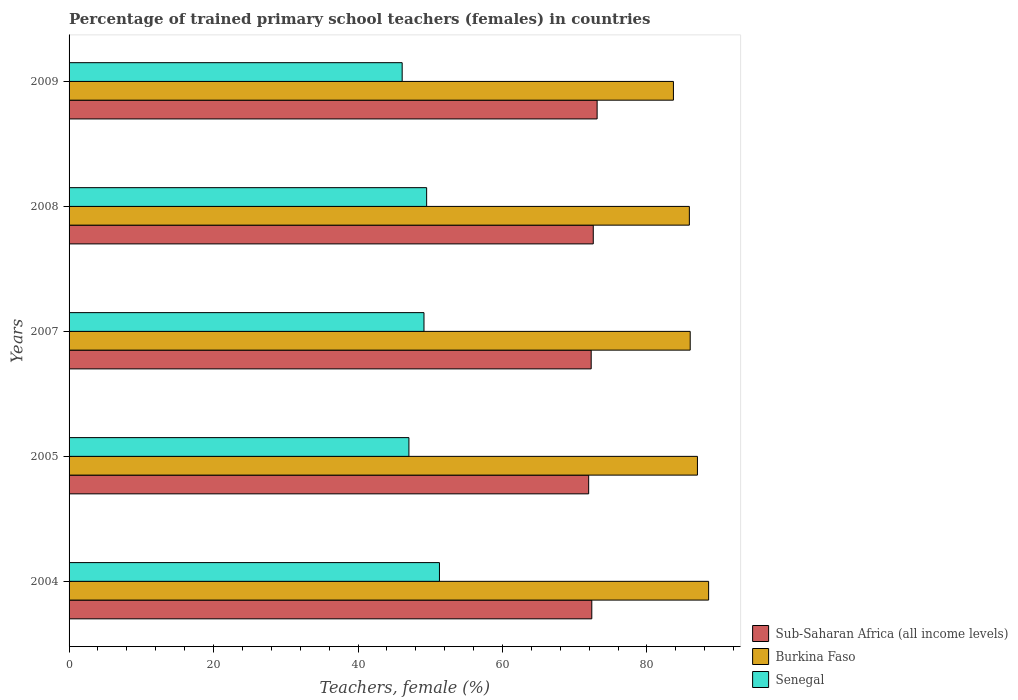How many groups of bars are there?
Your answer should be very brief. 5. How many bars are there on the 1st tick from the bottom?
Provide a succinct answer. 3. What is the label of the 4th group of bars from the top?
Keep it short and to the point. 2005. What is the percentage of trained primary school teachers (females) in Burkina Faso in 2007?
Provide a short and direct response. 85.99. Across all years, what is the maximum percentage of trained primary school teachers (females) in Burkina Faso?
Your answer should be very brief. 88.54. Across all years, what is the minimum percentage of trained primary school teachers (females) in Burkina Faso?
Make the answer very short. 83.67. What is the total percentage of trained primary school teachers (females) in Sub-Saharan Africa (all income levels) in the graph?
Provide a succinct answer. 362.25. What is the difference between the percentage of trained primary school teachers (females) in Senegal in 2007 and that in 2009?
Offer a very short reply. 3.02. What is the difference between the percentage of trained primary school teachers (females) in Sub-Saharan Africa (all income levels) in 2005 and the percentage of trained primary school teachers (females) in Burkina Faso in 2008?
Provide a short and direct response. -13.94. What is the average percentage of trained primary school teachers (females) in Burkina Faso per year?
Make the answer very short. 86.21. In the year 2009, what is the difference between the percentage of trained primary school teachers (females) in Burkina Faso and percentage of trained primary school teachers (females) in Senegal?
Give a very brief answer. 37.55. In how many years, is the percentage of trained primary school teachers (females) in Sub-Saharan Africa (all income levels) greater than 52 %?
Give a very brief answer. 5. What is the ratio of the percentage of trained primary school teachers (females) in Burkina Faso in 2007 to that in 2009?
Offer a terse response. 1.03. Is the percentage of trained primary school teachers (females) in Burkina Faso in 2004 less than that in 2009?
Provide a short and direct response. No. Is the difference between the percentage of trained primary school teachers (females) in Burkina Faso in 2004 and 2009 greater than the difference between the percentage of trained primary school teachers (females) in Senegal in 2004 and 2009?
Your response must be concise. No. What is the difference between the highest and the second highest percentage of trained primary school teachers (females) in Burkina Faso?
Make the answer very short. 1.55. What is the difference between the highest and the lowest percentage of trained primary school teachers (females) in Sub-Saharan Africa (all income levels)?
Offer a terse response. 1.17. In how many years, is the percentage of trained primary school teachers (females) in Sub-Saharan Africa (all income levels) greater than the average percentage of trained primary school teachers (females) in Sub-Saharan Africa (all income levels) taken over all years?
Your response must be concise. 2. What does the 3rd bar from the top in 2008 represents?
Offer a very short reply. Sub-Saharan Africa (all income levels). What does the 1st bar from the bottom in 2009 represents?
Offer a terse response. Sub-Saharan Africa (all income levels). How many bars are there?
Your answer should be very brief. 15. Are all the bars in the graph horizontal?
Your answer should be compact. Yes. What is the difference between two consecutive major ticks on the X-axis?
Your response must be concise. 20. Does the graph contain any zero values?
Offer a very short reply. No. How many legend labels are there?
Ensure brevity in your answer.  3. How are the legend labels stacked?
Your response must be concise. Vertical. What is the title of the graph?
Offer a terse response. Percentage of trained primary school teachers (females) in countries. Does "Oman" appear as one of the legend labels in the graph?
Give a very brief answer. No. What is the label or title of the X-axis?
Your answer should be very brief. Teachers, female (%). What is the Teachers, female (%) in Sub-Saharan Africa (all income levels) in 2004?
Provide a succinct answer. 72.37. What is the Teachers, female (%) in Burkina Faso in 2004?
Give a very brief answer. 88.54. What is the Teachers, female (%) in Senegal in 2004?
Your answer should be compact. 51.28. What is the Teachers, female (%) in Sub-Saharan Africa (all income levels) in 2005?
Provide a short and direct response. 71.93. What is the Teachers, female (%) of Burkina Faso in 2005?
Offer a terse response. 86.99. What is the Teachers, female (%) in Senegal in 2005?
Offer a very short reply. 47.05. What is the Teachers, female (%) of Sub-Saharan Africa (all income levels) in 2007?
Provide a short and direct response. 72.28. What is the Teachers, female (%) of Burkina Faso in 2007?
Keep it short and to the point. 85.99. What is the Teachers, female (%) of Senegal in 2007?
Your answer should be compact. 49.13. What is the Teachers, female (%) of Sub-Saharan Africa (all income levels) in 2008?
Provide a succinct answer. 72.57. What is the Teachers, female (%) of Burkina Faso in 2008?
Keep it short and to the point. 85.87. What is the Teachers, female (%) of Senegal in 2008?
Your response must be concise. 49.5. What is the Teachers, female (%) in Sub-Saharan Africa (all income levels) in 2009?
Keep it short and to the point. 73.1. What is the Teachers, female (%) in Burkina Faso in 2009?
Your answer should be very brief. 83.67. What is the Teachers, female (%) in Senegal in 2009?
Ensure brevity in your answer.  46.11. Across all years, what is the maximum Teachers, female (%) in Sub-Saharan Africa (all income levels)?
Give a very brief answer. 73.1. Across all years, what is the maximum Teachers, female (%) of Burkina Faso?
Offer a very short reply. 88.54. Across all years, what is the maximum Teachers, female (%) in Senegal?
Offer a terse response. 51.28. Across all years, what is the minimum Teachers, female (%) in Sub-Saharan Africa (all income levels)?
Your answer should be very brief. 71.93. Across all years, what is the minimum Teachers, female (%) in Burkina Faso?
Keep it short and to the point. 83.67. Across all years, what is the minimum Teachers, female (%) of Senegal?
Your response must be concise. 46.11. What is the total Teachers, female (%) in Sub-Saharan Africa (all income levels) in the graph?
Keep it short and to the point. 362.25. What is the total Teachers, female (%) of Burkina Faso in the graph?
Keep it short and to the point. 431.06. What is the total Teachers, female (%) in Senegal in the graph?
Make the answer very short. 243.07. What is the difference between the Teachers, female (%) of Sub-Saharan Africa (all income levels) in 2004 and that in 2005?
Make the answer very short. 0.43. What is the difference between the Teachers, female (%) in Burkina Faso in 2004 and that in 2005?
Provide a succinct answer. 1.55. What is the difference between the Teachers, female (%) in Senegal in 2004 and that in 2005?
Ensure brevity in your answer.  4.23. What is the difference between the Teachers, female (%) of Sub-Saharan Africa (all income levels) in 2004 and that in 2007?
Ensure brevity in your answer.  0.09. What is the difference between the Teachers, female (%) of Burkina Faso in 2004 and that in 2007?
Your response must be concise. 2.55. What is the difference between the Teachers, female (%) of Senegal in 2004 and that in 2007?
Your answer should be compact. 2.14. What is the difference between the Teachers, female (%) in Sub-Saharan Africa (all income levels) in 2004 and that in 2008?
Ensure brevity in your answer.  -0.2. What is the difference between the Teachers, female (%) in Burkina Faso in 2004 and that in 2008?
Make the answer very short. 2.67. What is the difference between the Teachers, female (%) of Senegal in 2004 and that in 2008?
Give a very brief answer. 1.77. What is the difference between the Teachers, female (%) of Sub-Saharan Africa (all income levels) in 2004 and that in 2009?
Make the answer very short. -0.74. What is the difference between the Teachers, female (%) of Burkina Faso in 2004 and that in 2009?
Provide a succinct answer. 4.87. What is the difference between the Teachers, female (%) of Senegal in 2004 and that in 2009?
Provide a succinct answer. 5.16. What is the difference between the Teachers, female (%) in Sub-Saharan Africa (all income levels) in 2005 and that in 2007?
Offer a terse response. -0.35. What is the difference between the Teachers, female (%) of Burkina Faso in 2005 and that in 2007?
Keep it short and to the point. 1. What is the difference between the Teachers, female (%) of Senegal in 2005 and that in 2007?
Make the answer very short. -2.08. What is the difference between the Teachers, female (%) of Sub-Saharan Africa (all income levels) in 2005 and that in 2008?
Provide a succinct answer. -0.64. What is the difference between the Teachers, female (%) of Burkina Faso in 2005 and that in 2008?
Provide a short and direct response. 1.12. What is the difference between the Teachers, female (%) in Senegal in 2005 and that in 2008?
Make the answer very short. -2.45. What is the difference between the Teachers, female (%) in Sub-Saharan Africa (all income levels) in 2005 and that in 2009?
Your answer should be compact. -1.17. What is the difference between the Teachers, female (%) of Burkina Faso in 2005 and that in 2009?
Provide a short and direct response. 3.33. What is the difference between the Teachers, female (%) of Senegal in 2005 and that in 2009?
Your answer should be very brief. 0.93. What is the difference between the Teachers, female (%) in Sub-Saharan Africa (all income levels) in 2007 and that in 2008?
Your response must be concise. -0.29. What is the difference between the Teachers, female (%) in Burkina Faso in 2007 and that in 2008?
Your response must be concise. 0.12. What is the difference between the Teachers, female (%) in Senegal in 2007 and that in 2008?
Keep it short and to the point. -0.37. What is the difference between the Teachers, female (%) in Sub-Saharan Africa (all income levels) in 2007 and that in 2009?
Give a very brief answer. -0.82. What is the difference between the Teachers, female (%) of Burkina Faso in 2007 and that in 2009?
Your answer should be very brief. 2.32. What is the difference between the Teachers, female (%) in Senegal in 2007 and that in 2009?
Offer a terse response. 3.02. What is the difference between the Teachers, female (%) in Sub-Saharan Africa (all income levels) in 2008 and that in 2009?
Give a very brief answer. -0.53. What is the difference between the Teachers, female (%) of Burkina Faso in 2008 and that in 2009?
Your answer should be compact. 2.21. What is the difference between the Teachers, female (%) of Senegal in 2008 and that in 2009?
Give a very brief answer. 3.39. What is the difference between the Teachers, female (%) in Sub-Saharan Africa (all income levels) in 2004 and the Teachers, female (%) in Burkina Faso in 2005?
Keep it short and to the point. -14.62. What is the difference between the Teachers, female (%) in Sub-Saharan Africa (all income levels) in 2004 and the Teachers, female (%) in Senegal in 2005?
Provide a succinct answer. 25.32. What is the difference between the Teachers, female (%) of Burkina Faso in 2004 and the Teachers, female (%) of Senegal in 2005?
Ensure brevity in your answer.  41.49. What is the difference between the Teachers, female (%) in Sub-Saharan Africa (all income levels) in 2004 and the Teachers, female (%) in Burkina Faso in 2007?
Your answer should be compact. -13.62. What is the difference between the Teachers, female (%) of Sub-Saharan Africa (all income levels) in 2004 and the Teachers, female (%) of Senegal in 2007?
Make the answer very short. 23.23. What is the difference between the Teachers, female (%) of Burkina Faso in 2004 and the Teachers, female (%) of Senegal in 2007?
Your response must be concise. 39.41. What is the difference between the Teachers, female (%) in Sub-Saharan Africa (all income levels) in 2004 and the Teachers, female (%) in Burkina Faso in 2008?
Offer a terse response. -13.51. What is the difference between the Teachers, female (%) of Sub-Saharan Africa (all income levels) in 2004 and the Teachers, female (%) of Senegal in 2008?
Give a very brief answer. 22.86. What is the difference between the Teachers, female (%) in Burkina Faso in 2004 and the Teachers, female (%) in Senegal in 2008?
Offer a terse response. 39.04. What is the difference between the Teachers, female (%) in Sub-Saharan Africa (all income levels) in 2004 and the Teachers, female (%) in Burkina Faso in 2009?
Offer a terse response. -11.3. What is the difference between the Teachers, female (%) of Sub-Saharan Africa (all income levels) in 2004 and the Teachers, female (%) of Senegal in 2009?
Offer a terse response. 26.25. What is the difference between the Teachers, female (%) in Burkina Faso in 2004 and the Teachers, female (%) in Senegal in 2009?
Provide a short and direct response. 42.42. What is the difference between the Teachers, female (%) in Sub-Saharan Africa (all income levels) in 2005 and the Teachers, female (%) in Burkina Faso in 2007?
Your answer should be compact. -14.06. What is the difference between the Teachers, female (%) in Sub-Saharan Africa (all income levels) in 2005 and the Teachers, female (%) in Senegal in 2007?
Keep it short and to the point. 22.8. What is the difference between the Teachers, female (%) in Burkina Faso in 2005 and the Teachers, female (%) in Senegal in 2007?
Your response must be concise. 37.86. What is the difference between the Teachers, female (%) of Sub-Saharan Africa (all income levels) in 2005 and the Teachers, female (%) of Burkina Faso in 2008?
Ensure brevity in your answer.  -13.94. What is the difference between the Teachers, female (%) in Sub-Saharan Africa (all income levels) in 2005 and the Teachers, female (%) in Senegal in 2008?
Your answer should be compact. 22.43. What is the difference between the Teachers, female (%) in Burkina Faso in 2005 and the Teachers, female (%) in Senegal in 2008?
Provide a succinct answer. 37.49. What is the difference between the Teachers, female (%) of Sub-Saharan Africa (all income levels) in 2005 and the Teachers, female (%) of Burkina Faso in 2009?
Your response must be concise. -11.73. What is the difference between the Teachers, female (%) of Sub-Saharan Africa (all income levels) in 2005 and the Teachers, female (%) of Senegal in 2009?
Your response must be concise. 25.82. What is the difference between the Teachers, female (%) of Burkina Faso in 2005 and the Teachers, female (%) of Senegal in 2009?
Your response must be concise. 40.88. What is the difference between the Teachers, female (%) of Sub-Saharan Africa (all income levels) in 2007 and the Teachers, female (%) of Burkina Faso in 2008?
Your response must be concise. -13.59. What is the difference between the Teachers, female (%) of Sub-Saharan Africa (all income levels) in 2007 and the Teachers, female (%) of Senegal in 2008?
Keep it short and to the point. 22.78. What is the difference between the Teachers, female (%) of Burkina Faso in 2007 and the Teachers, female (%) of Senegal in 2008?
Ensure brevity in your answer.  36.49. What is the difference between the Teachers, female (%) in Sub-Saharan Africa (all income levels) in 2007 and the Teachers, female (%) in Burkina Faso in 2009?
Offer a very short reply. -11.39. What is the difference between the Teachers, female (%) in Sub-Saharan Africa (all income levels) in 2007 and the Teachers, female (%) in Senegal in 2009?
Offer a very short reply. 26.17. What is the difference between the Teachers, female (%) in Burkina Faso in 2007 and the Teachers, female (%) in Senegal in 2009?
Make the answer very short. 39.87. What is the difference between the Teachers, female (%) in Sub-Saharan Africa (all income levels) in 2008 and the Teachers, female (%) in Burkina Faso in 2009?
Your answer should be very brief. -11.1. What is the difference between the Teachers, female (%) in Sub-Saharan Africa (all income levels) in 2008 and the Teachers, female (%) in Senegal in 2009?
Offer a terse response. 26.46. What is the difference between the Teachers, female (%) in Burkina Faso in 2008 and the Teachers, female (%) in Senegal in 2009?
Give a very brief answer. 39.76. What is the average Teachers, female (%) of Sub-Saharan Africa (all income levels) per year?
Give a very brief answer. 72.45. What is the average Teachers, female (%) of Burkina Faso per year?
Give a very brief answer. 86.21. What is the average Teachers, female (%) in Senegal per year?
Your answer should be very brief. 48.61. In the year 2004, what is the difference between the Teachers, female (%) of Sub-Saharan Africa (all income levels) and Teachers, female (%) of Burkina Faso?
Provide a succinct answer. -16.17. In the year 2004, what is the difference between the Teachers, female (%) of Sub-Saharan Africa (all income levels) and Teachers, female (%) of Senegal?
Offer a terse response. 21.09. In the year 2004, what is the difference between the Teachers, female (%) of Burkina Faso and Teachers, female (%) of Senegal?
Provide a short and direct response. 37.26. In the year 2005, what is the difference between the Teachers, female (%) of Sub-Saharan Africa (all income levels) and Teachers, female (%) of Burkina Faso?
Offer a very short reply. -15.06. In the year 2005, what is the difference between the Teachers, female (%) in Sub-Saharan Africa (all income levels) and Teachers, female (%) in Senegal?
Offer a very short reply. 24.88. In the year 2005, what is the difference between the Teachers, female (%) of Burkina Faso and Teachers, female (%) of Senegal?
Ensure brevity in your answer.  39.94. In the year 2007, what is the difference between the Teachers, female (%) of Sub-Saharan Africa (all income levels) and Teachers, female (%) of Burkina Faso?
Ensure brevity in your answer.  -13.71. In the year 2007, what is the difference between the Teachers, female (%) of Sub-Saharan Africa (all income levels) and Teachers, female (%) of Senegal?
Your response must be concise. 23.15. In the year 2007, what is the difference between the Teachers, female (%) of Burkina Faso and Teachers, female (%) of Senegal?
Your answer should be compact. 36.86. In the year 2008, what is the difference between the Teachers, female (%) in Sub-Saharan Africa (all income levels) and Teachers, female (%) in Burkina Faso?
Your answer should be very brief. -13.3. In the year 2008, what is the difference between the Teachers, female (%) in Sub-Saharan Africa (all income levels) and Teachers, female (%) in Senegal?
Provide a short and direct response. 23.07. In the year 2008, what is the difference between the Teachers, female (%) in Burkina Faso and Teachers, female (%) in Senegal?
Your answer should be compact. 36.37. In the year 2009, what is the difference between the Teachers, female (%) of Sub-Saharan Africa (all income levels) and Teachers, female (%) of Burkina Faso?
Ensure brevity in your answer.  -10.56. In the year 2009, what is the difference between the Teachers, female (%) of Sub-Saharan Africa (all income levels) and Teachers, female (%) of Senegal?
Make the answer very short. 26.99. In the year 2009, what is the difference between the Teachers, female (%) in Burkina Faso and Teachers, female (%) in Senegal?
Ensure brevity in your answer.  37.55. What is the ratio of the Teachers, female (%) of Sub-Saharan Africa (all income levels) in 2004 to that in 2005?
Your answer should be very brief. 1.01. What is the ratio of the Teachers, female (%) of Burkina Faso in 2004 to that in 2005?
Give a very brief answer. 1.02. What is the ratio of the Teachers, female (%) of Senegal in 2004 to that in 2005?
Your answer should be compact. 1.09. What is the ratio of the Teachers, female (%) in Sub-Saharan Africa (all income levels) in 2004 to that in 2007?
Make the answer very short. 1. What is the ratio of the Teachers, female (%) in Burkina Faso in 2004 to that in 2007?
Offer a terse response. 1.03. What is the ratio of the Teachers, female (%) of Senegal in 2004 to that in 2007?
Make the answer very short. 1.04. What is the ratio of the Teachers, female (%) in Burkina Faso in 2004 to that in 2008?
Offer a terse response. 1.03. What is the ratio of the Teachers, female (%) of Senegal in 2004 to that in 2008?
Provide a succinct answer. 1.04. What is the ratio of the Teachers, female (%) in Burkina Faso in 2004 to that in 2009?
Make the answer very short. 1.06. What is the ratio of the Teachers, female (%) of Senegal in 2004 to that in 2009?
Keep it short and to the point. 1.11. What is the ratio of the Teachers, female (%) of Sub-Saharan Africa (all income levels) in 2005 to that in 2007?
Provide a succinct answer. 1. What is the ratio of the Teachers, female (%) of Burkina Faso in 2005 to that in 2007?
Your answer should be compact. 1.01. What is the ratio of the Teachers, female (%) in Senegal in 2005 to that in 2007?
Your response must be concise. 0.96. What is the ratio of the Teachers, female (%) of Sub-Saharan Africa (all income levels) in 2005 to that in 2008?
Keep it short and to the point. 0.99. What is the ratio of the Teachers, female (%) of Burkina Faso in 2005 to that in 2008?
Your answer should be very brief. 1.01. What is the ratio of the Teachers, female (%) in Senegal in 2005 to that in 2008?
Give a very brief answer. 0.95. What is the ratio of the Teachers, female (%) of Burkina Faso in 2005 to that in 2009?
Make the answer very short. 1.04. What is the ratio of the Teachers, female (%) of Senegal in 2005 to that in 2009?
Provide a short and direct response. 1.02. What is the ratio of the Teachers, female (%) of Sub-Saharan Africa (all income levels) in 2007 to that in 2008?
Offer a terse response. 1. What is the ratio of the Teachers, female (%) of Burkina Faso in 2007 to that in 2008?
Ensure brevity in your answer.  1. What is the ratio of the Teachers, female (%) of Sub-Saharan Africa (all income levels) in 2007 to that in 2009?
Keep it short and to the point. 0.99. What is the ratio of the Teachers, female (%) in Burkina Faso in 2007 to that in 2009?
Ensure brevity in your answer.  1.03. What is the ratio of the Teachers, female (%) in Senegal in 2007 to that in 2009?
Offer a very short reply. 1.07. What is the ratio of the Teachers, female (%) of Sub-Saharan Africa (all income levels) in 2008 to that in 2009?
Provide a short and direct response. 0.99. What is the ratio of the Teachers, female (%) of Burkina Faso in 2008 to that in 2009?
Keep it short and to the point. 1.03. What is the ratio of the Teachers, female (%) of Senegal in 2008 to that in 2009?
Provide a succinct answer. 1.07. What is the difference between the highest and the second highest Teachers, female (%) in Sub-Saharan Africa (all income levels)?
Ensure brevity in your answer.  0.53. What is the difference between the highest and the second highest Teachers, female (%) of Burkina Faso?
Your response must be concise. 1.55. What is the difference between the highest and the second highest Teachers, female (%) of Senegal?
Keep it short and to the point. 1.77. What is the difference between the highest and the lowest Teachers, female (%) of Sub-Saharan Africa (all income levels)?
Keep it short and to the point. 1.17. What is the difference between the highest and the lowest Teachers, female (%) in Burkina Faso?
Provide a succinct answer. 4.87. What is the difference between the highest and the lowest Teachers, female (%) of Senegal?
Give a very brief answer. 5.16. 